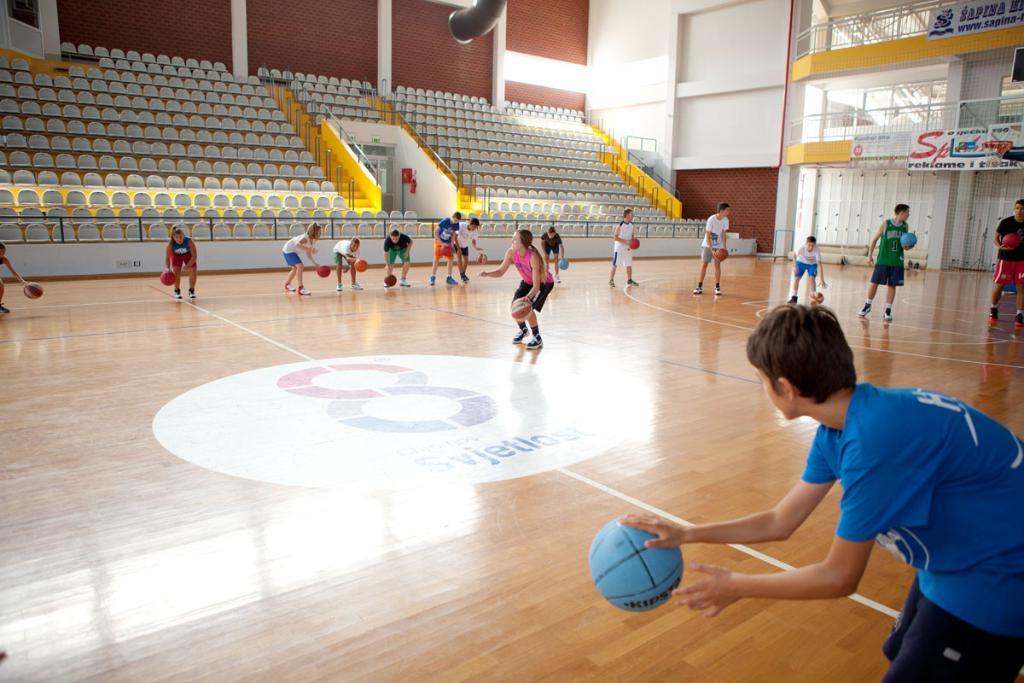What number is in the middle of the court?
Offer a very short reply. 8. What is the first word of the top banner in the background?
Your answer should be compact. Sapina. 